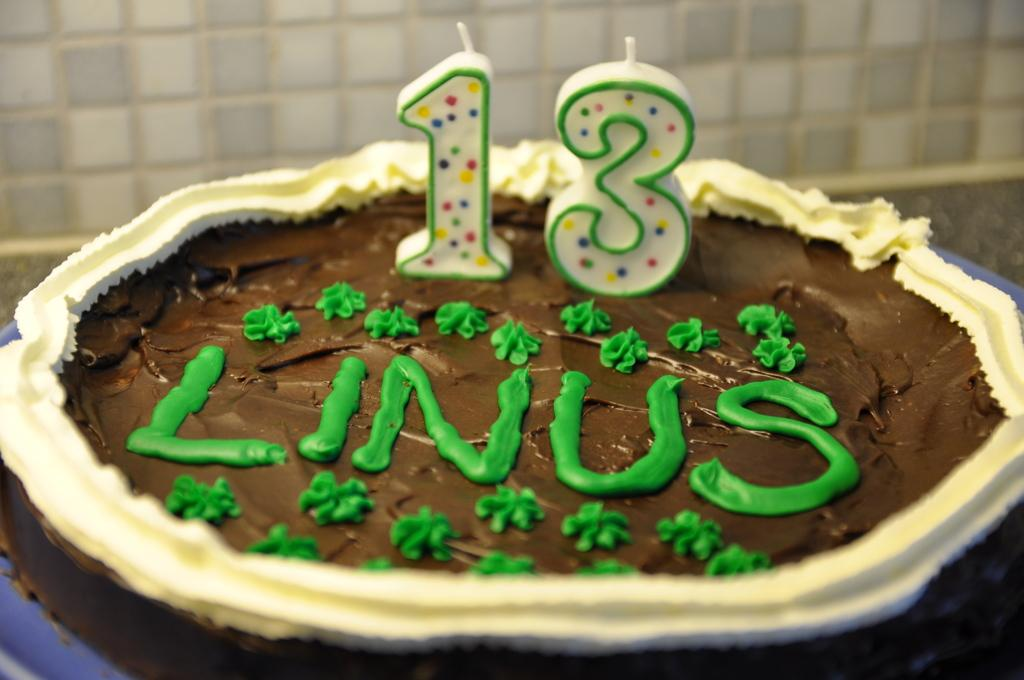What is the main subject of the image? There is a cake in the image. How many candles are on the cake? The cake has 13 candles on it. What type of beef is being cooked on the lamp in the image? There is no lamp or beef present in the image; it only features a cake with candles. 